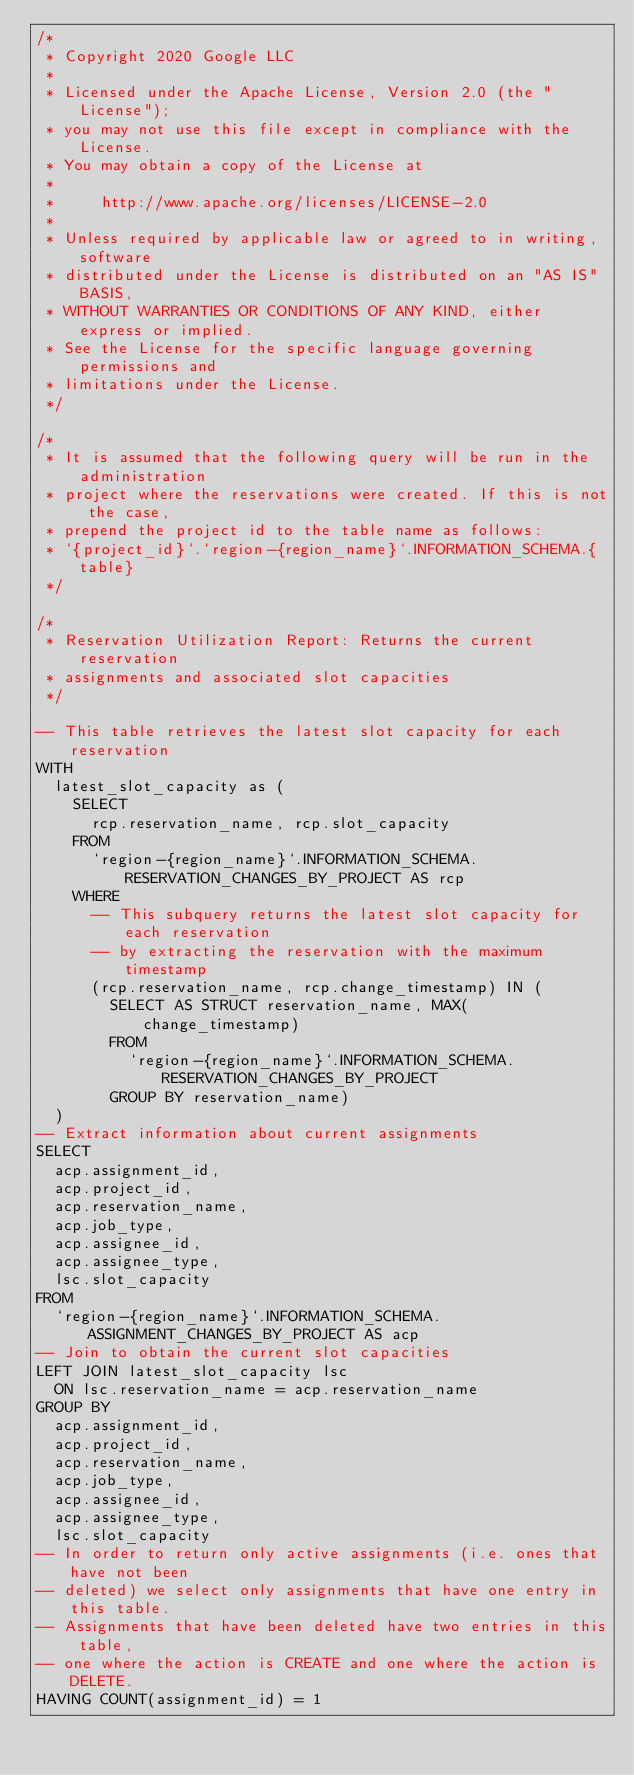Convert code to text. <code><loc_0><loc_0><loc_500><loc_500><_SQL_>/*
 * Copyright 2020 Google LLC
 *
 * Licensed under the Apache License, Version 2.0 (the "License");
 * you may not use this file except in compliance with the License.
 * You may obtain a copy of the License at
 *
 *     http://www.apache.org/licenses/LICENSE-2.0
 *
 * Unless required by applicable law or agreed to in writing, software
 * distributed under the License is distributed on an "AS IS" BASIS,
 * WITHOUT WARRANTIES OR CONDITIONS OF ANY KIND, either express or implied.
 * See the License for the specific language governing permissions and
 * limitations under the License.
 */

/*
 * It is assumed that the following query will be run in the administration
 * project where the reservations were created. If this is not the case,
 * prepend the project id to the table name as follows:
 * `{project_id}`.`region-{region_name}`.INFORMATION_SCHEMA.{table}
 */

/*
 * Reservation Utilization Report: Returns the current reservation
 * assignments and associated slot capacities
 */

-- This table retrieves the latest slot capacity for each reservation
WITH
  latest_slot_capacity as (
    SELECT
      rcp.reservation_name, rcp.slot_capacity
    FROM
      `region-{region_name}`.INFORMATION_SCHEMA.RESERVATION_CHANGES_BY_PROJECT AS rcp
    WHERE
      -- This subquery returns the latest slot capacity for each reservation
      -- by extracting the reservation with the maximum timestamp
      (rcp.reservation_name, rcp.change_timestamp) IN (
        SELECT AS STRUCT reservation_name, MAX(change_timestamp)
        FROM
          `region-{region_name}`.INFORMATION_SCHEMA.RESERVATION_CHANGES_BY_PROJECT
        GROUP BY reservation_name)
  )
-- Extract information about current assignments
SELECT
  acp.assignment_id,
  acp.project_id,
  acp.reservation_name,
  acp.job_type,
  acp.assignee_id,
  acp.assignee_type,
  lsc.slot_capacity
FROM
  `region-{region_name}`.INFORMATION_SCHEMA.ASSIGNMENT_CHANGES_BY_PROJECT AS acp
-- Join to obtain the current slot capacities
LEFT JOIN latest_slot_capacity lsc
  ON lsc.reservation_name = acp.reservation_name
GROUP BY
  acp.assignment_id,
  acp.project_id,
  acp.reservation_name,
  acp.job_type,
  acp.assignee_id,
  acp.assignee_type,
  lsc.slot_capacity
-- In order to return only active assignments (i.e. ones that have not been
-- deleted) we select only assignments that have one entry in this table.
-- Assignments that have been deleted have two entries in this table,
-- one where the action is CREATE and one where the action is DELETE.
HAVING COUNT(assignment_id) = 1
</code> 